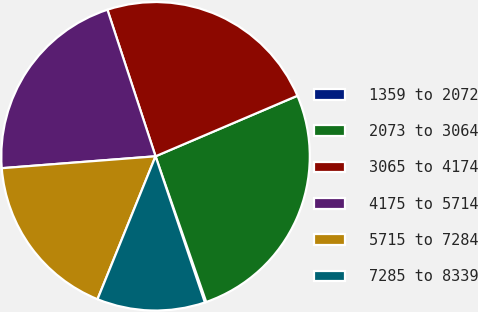Convert chart. <chart><loc_0><loc_0><loc_500><loc_500><pie_chart><fcel>1359 to 2072<fcel>2073 to 3064<fcel>3065 to 4174<fcel>4175 to 5714<fcel>5715 to 7284<fcel>7285 to 8339<nl><fcel>0.15%<fcel>26.09%<fcel>23.63%<fcel>21.18%<fcel>17.63%<fcel>11.32%<nl></chart> 